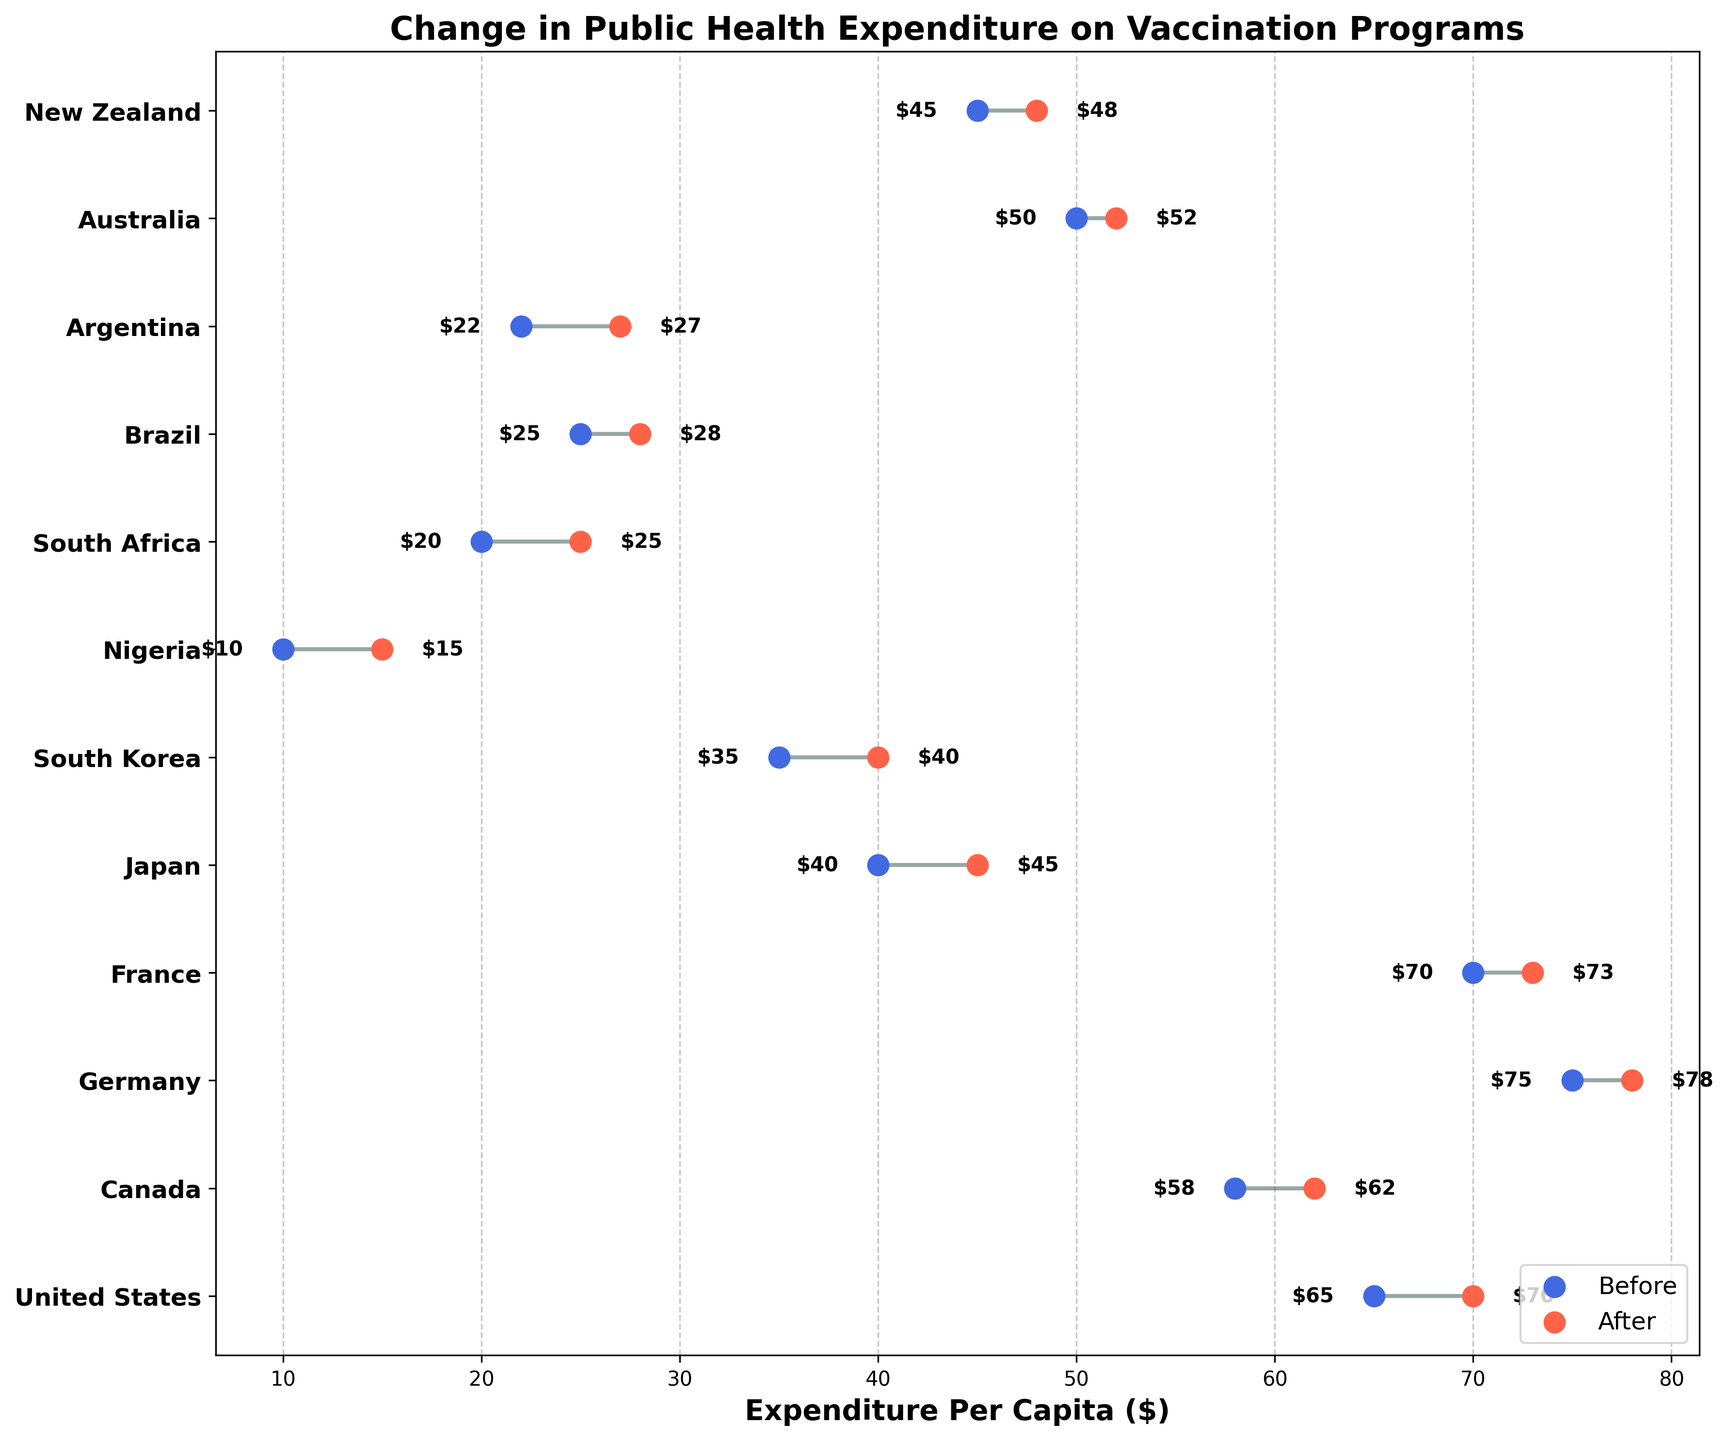What is the title of the figure? The title of the figure is displayed at the top and it reads "Change in Public Health Expenditure on Vaccination Programs".
Answer: Change in Public Health Expenditure on Vaccination Programs How many countries increased their expenditure on vaccination programs? By looking at the endpoints of the dumbbell plots, where the 'After' value is higher than the 'Before' value, we can count 12 countries showing an increase.
Answer: 12 Which country had the highest increase in expenditure per capita? By examining the lengths of the lines in the dumbbell plot, Nigeria has the largest increase from $10 to $15. To find the increase, subtract $10 from $15, which equals $5.
Answer: Nigeria What was the change in public health expenditure for South Korea? South Korea's expenditure changed from $35 to $40. Subtract $35 from $40 to find the increase, which is $5.
Answer: $5 Which region has the largest range in public health expenditure values? Comparing the ranges (difference between highest and lowest values) of all regions, Europe has a range from $70 to $78 ($8), while North America ranges from $62 to $70 ($8), Asia from $40 to $45 ($5), Africa from $10 to $25 ($15), South America from $22 to $28 ($6), and Oceania from $45 to $52 ($7). Africa has the largest range of $15.
Answer: Africa Which European country had a greater increase in expenditure, Germany or France? Germany's expenditure increased from $75 to $78 ($3 increase), while France's expenditure increased from $70 to $73 ($3 increase). Comparing both increases, they are equal.
Answer: Both had equal increases What is the average after-expenditure for Oceania? Oceania includes Australia and New Zealand. Their expenditures after are $52 and $48 respectively. Adding these gives $100, and dividing by 2 gives an average of $50.
Answer: $50 Which country in South America had a higher expenditure before the program change? Comparing Brazil's and Argentina's 'Before' expenditures, Brazil had $25, and Argentina had $22. Therefore, Brazil had a higher 'Before' expenditure.
Answer: Brazil Is there any country with no change in expenditure? Visually examining if any line is of zero length, no such country can be found. Every country shows some change.
Answer: None How much more did the United States spend per capita on vaccination programs in 2020 compared to Japan after the increase? The US's after-expenditure is $70, and Japan's is $45. Subtract $45 from $70 to find the difference, which is $25.
Answer: $25 